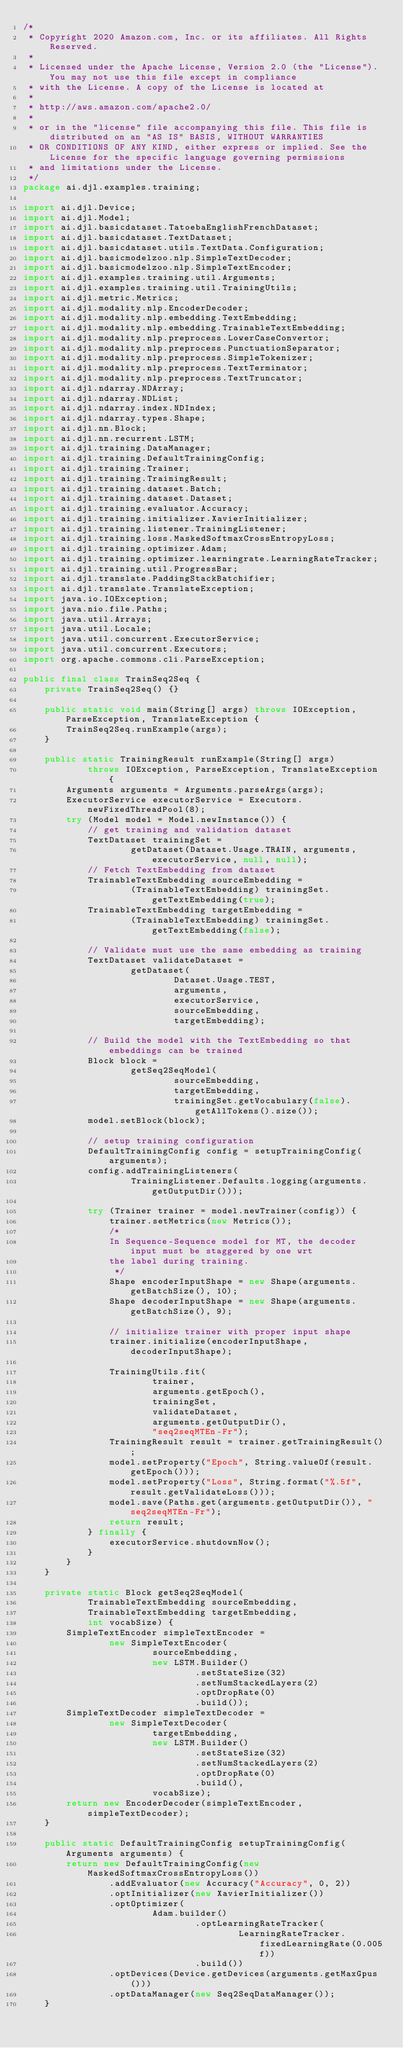Convert code to text. <code><loc_0><loc_0><loc_500><loc_500><_Java_>/*
 * Copyright 2020 Amazon.com, Inc. or its affiliates. All Rights Reserved.
 *
 * Licensed under the Apache License, Version 2.0 (the "License"). You may not use this file except in compliance
 * with the License. A copy of the License is located at
 *
 * http://aws.amazon.com/apache2.0/
 *
 * or in the "license" file accompanying this file. This file is distributed on an "AS IS" BASIS, WITHOUT WARRANTIES
 * OR CONDITIONS OF ANY KIND, either express or implied. See the License for the specific language governing permissions
 * and limitations under the License.
 */
package ai.djl.examples.training;

import ai.djl.Device;
import ai.djl.Model;
import ai.djl.basicdataset.TatoebaEnglishFrenchDataset;
import ai.djl.basicdataset.TextDataset;
import ai.djl.basicdataset.utils.TextData.Configuration;
import ai.djl.basicmodelzoo.nlp.SimpleTextDecoder;
import ai.djl.basicmodelzoo.nlp.SimpleTextEncoder;
import ai.djl.examples.training.util.Arguments;
import ai.djl.examples.training.util.TrainingUtils;
import ai.djl.metric.Metrics;
import ai.djl.modality.nlp.EncoderDecoder;
import ai.djl.modality.nlp.embedding.TextEmbedding;
import ai.djl.modality.nlp.embedding.TrainableTextEmbedding;
import ai.djl.modality.nlp.preprocess.LowerCaseConvertor;
import ai.djl.modality.nlp.preprocess.PunctuationSeparator;
import ai.djl.modality.nlp.preprocess.SimpleTokenizer;
import ai.djl.modality.nlp.preprocess.TextTerminator;
import ai.djl.modality.nlp.preprocess.TextTruncator;
import ai.djl.ndarray.NDArray;
import ai.djl.ndarray.NDList;
import ai.djl.ndarray.index.NDIndex;
import ai.djl.ndarray.types.Shape;
import ai.djl.nn.Block;
import ai.djl.nn.recurrent.LSTM;
import ai.djl.training.DataManager;
import ai.djl.training.DefaultTrainingConfig;
import ai.djl.training.Trainer;
import ai.djl.training.TrainingResult;
import ai.djl.training.dataset.Batch;
import ai.djl.training.dataset.Dataset;
import ai.djl.training.evaluator.Accuracy;
import ai.djl.training.initializer.XavierInitializer;
import ai.djl.training.listener.TrainingListener;
import ai.djl.training.loss.MaskedSoftmaxCrossEntropyLoss;
import ai.djl.training.optimizer.Adam;
import ai.djl.training.optimizer.learningrate.LearningRateTracker;
import ai.djl.training.util.ProgressBar;
import ai.djl.translate.PaddingStackBatchifier;
import ai.djl.translate.TranslateException;
import java.io.IOException;
import java.nio.file.Paths;
import java.util.Arrays;
import java.util.Locale;
import java.util.concurrent.ExecutorService;
import java.util.concurrent.Executors;
import org.apache.commons.cli.ParseException;

public final class TrainSeq2Seq {
    private TrainSeq2Seq() {}

    public static void main(String[] args) throws IOException, ParseException, TranslateException {
        TrainSeq2Seq.runExample(args);
    }

    public static TrainingResult runExample(String[] args)
            throws IOException, ParseException, TranslateException {
        Arguments arguments = Arguments.parseArgs(args);
        ExecutorService executorService = Executors.newFixedThreadPool(8);
        try (Model model = Model.newInstance()) {
            // get training and validation dataset
            TextDataset trainingSet =
                    getDataset(Dataset.Usage.TRAIN, arguments, executorService, null, null);
            // Fetch TextEmbedding from dataset
            TrainableTextEmbedding sourceEmbedding =
                    (TrainableTextEmbedding) trainingSet.getTextEmbedding(true);
            TrainableTextEmbedding targetEmbedding =
                    (TrainableTextEmbedding) trainingSet.getTextEmbedding(false);

            // Validate must use the same embedding as training
            TextDataset validateDataset =
                    getDataset(
                            Dataset.Usage.TEST,
                            arguments,
                            executorService,
                            sourceEmbedding,
                            targetEmbedding);

            // Build the model with the TextEmbedding so that embeddings can be trained
            Block block =
                    getSeq2SeqModel(
                            sourceEmbedding,
                            targetEmbedding,
                            trainingSet.getVocabulary(false).getAllTokens().size());
            model.setBlock(block);

            // setup training configuration
            DefaultTrainingConfig config = setupTrainingConfig(arguments);
            config.addTrainingListeners(
                    TrainingListener.Defaults.logging(arguments.getOutputDir()));

            try (Trainer trainer = model.newTrainer(config)) {
                trainer.setMetrics(new Metrics());
                /*
                In Sequence-Sequence model for MT, the decoder input must be staggered by one wrt
                the label during training.
                 */
                Shape encoderInputShape = new Shape(arguments.getBatchSize(), 10);
                Shape decoderInputShape = new Shape(arguments.getBatchSize(), 9);

                // initialize trainer with proper input shape
                trainer.initialize(encoderInputShape, decoderInputShape);

                TrainingUtils.fit(
                        trainer,
                        arguments.getEpoch(),
                        trainingSet,
                        validateDataset,
                        arguments.getOutputDir(),
                        "seq2seqMTEn-Fr");
                TrainingResult result = trainer.getTrainingResult();
                model.setProperty("Epoch", String.valueOf(result.getEpoch()));
                model.setProperty("Loss", String.format("%.5f", result.getValidateLoss()));
                model.save(Paths.get(arguments.getOutputDir()), "seq2seqMTEn-Fr");
                return result;
            } finally {
                executorService.shutdownNow();
            }
        }
    }

    private static Block getSeq2SeqModel(
            TrainableTextEmbedding sourceEmbedding,
            TrainableTextEmbedding targetEmbedding,
            int vocabSize) {
        SimpleTextEncoder simpleTextEncoder =
                new SimpleTextEncoder(
                        sourceEmbedding,
                        new LSTM.Builder()
                                .setStateSize(32)
                                .setNumStackedLayers(2)
                                .optDropRate(0)
                                .build());
        SimpleTextDecoder simpleTextDecoder =
                new SimpleTextDecoder(
                        targetEmbedding,
                        new LSTM.Builder()
                                .setStateSize(32)
                                .setNumStackedLayers(2)
                                .optDropRate(0)
                                .build(),
                        vocabSize);
        return new EncoderDecoder(simpleTextEncoder, simpleTextDecoder);
    }

    public static DefaultTrainingConfig setupTrainingConfig(Arguments arguments) {
        return new DefaultTrainingConfig(new MaskedSoftmaxCrossEntropyLoss())
                .addEvaluator(new Accuracy("Accuracy", 0, 2))
                .optInitializer(new XavierInitializer())
                .optOptimizer(
                        Adam.builder()
                                .optLearningRateTracker(
                                        LearningRateTracker.fixedLearningRate(0.005f))
                                .build())
                .optDevices(Device.getDevices(arguments.getMaxGpus()))
                .optDataManager(new Seq2SeqDataManager());
    }
</code> 